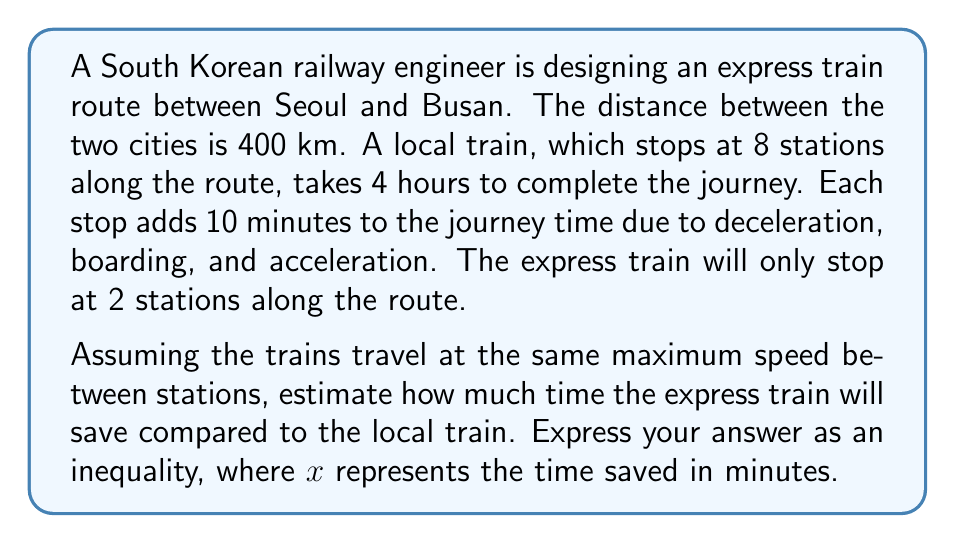Help me with this question. Let's approach this step-by-step:

1) First, calculate the total time spent on stops for the local train:
   $$8 \text{ stops} \times 10 \text{ minutes} = 80 \text{ minutes}$$

2) Calculate the actual travel time for the local train (excluding stops):
   $$4 \text{ hours} - 80 \text{ minutes} = 160 \text{ minutes}$$

3) For the express train, calculate the time spent on stops:
   $$2 \text{ stops} \times 10 \text{ minutes} = 20 \text{ minutes}$$

4) The express train will have the same travel time between stations as the local train (160 minutes) plus its stop time:
   $$160 \text{ minutes} + 20 \text{ minutes} = 180 \text{ minutes}$$

5) Calculate the time difference:
   $$240 \text{ minutes (local)} - 180 \text{ minutes (express)} = 60 \text{ minutes}$$

6) However, this calculation assumes perfect conditions. In reality, there might be slight variations due to factors like track conditions, weather, or minor delays. To account for this, we can express the time saved as an inequality:

   $$x > 55$$

   This inequality states that the time saved will be more than 55 minutes, allowing for a small margin of error while still providing a meaningful lower bound for the time savings.
Answer: $$x > 55$$
Where $x$ represents the time saved in minutes by the express train compared to the local train. 